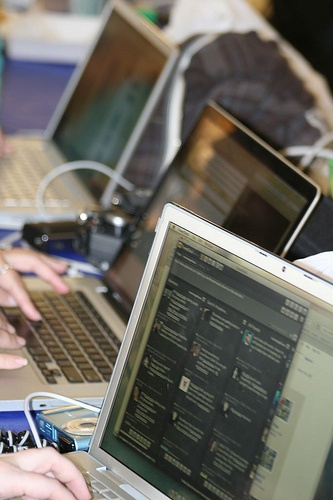Describe the objects in this image and their specific colors. I can see laptop in gray, black, darkgray, and white tones, laptop in gray, black, and darkgray tones, laptop in gray, darkgray, and maroon tones, keyboard in gray and tan tones, and keyboard in gray, darkgray, tan, and lightgray tones in this image. 